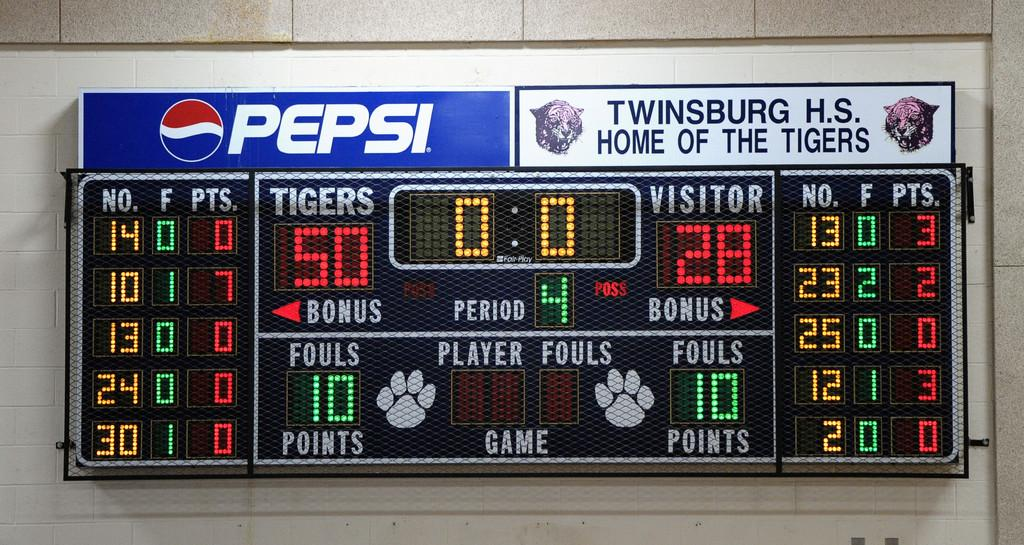Provide a one-sentence caption for the provided image. Scoreboard for Twinsburg High School sponsored by Pepsi. 